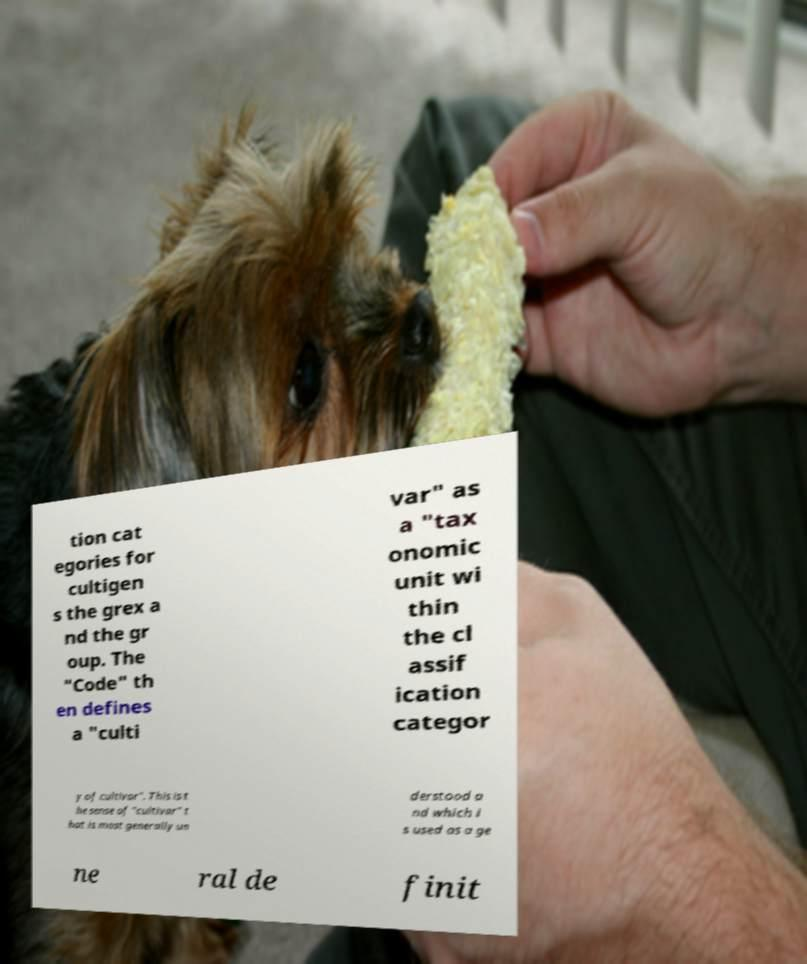For documentation purposes, I need the text within this image transcribed. Could you provide that? tion cat egories for cultigen s the grex a nd the gr oup. The "Code" th en defines a "culti var" as a "tax onomic unit wi thin the cl assif ication categor y of cultivar". This is t he sense of "cultivar" t hat is most generally un derstood a nd which i s used as a ge ne ral de finit 